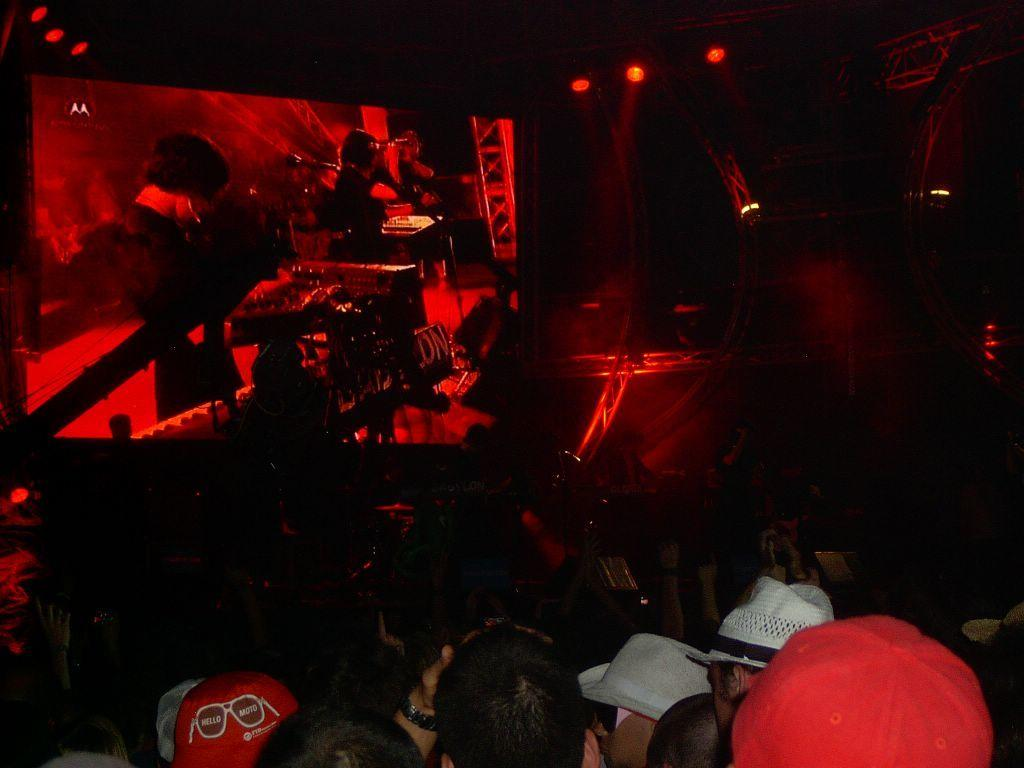What are the people in the image doing? The people in the image are sitting on chairs. What can be seen in the background of the image? There appears to be a screen in the background of the image. What type of lighting is present on the ceiling in the image? Red lights are visible on the ceiling in the image. What type of pleasure can be seen being derived from the need for friction in the image? There is no indication of pleasure, need, or friction in the image; it simply shows people sitting on chairs with a screen in the background and red lights on the ceiling. 